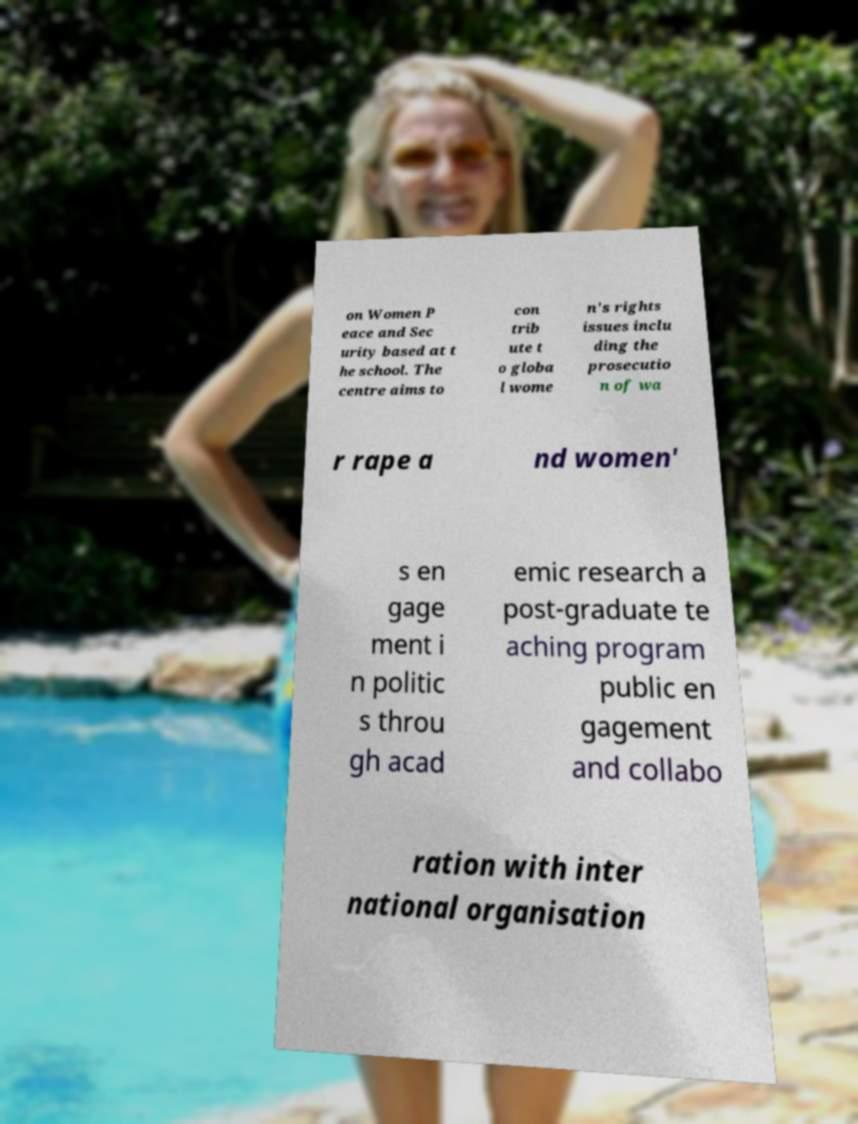Could you extract and type out the text from this image? on Women P eace and Sec urity based at t he school. The centre aims to con trib ute t o globa l wome n's rights issues inclu ding the prosecutio n of wa r rape a nd women' s en gage ment i n politic s throu gh acad emic research a post-graduate te aching program public en gagement and collabo ration with inter national organisation 